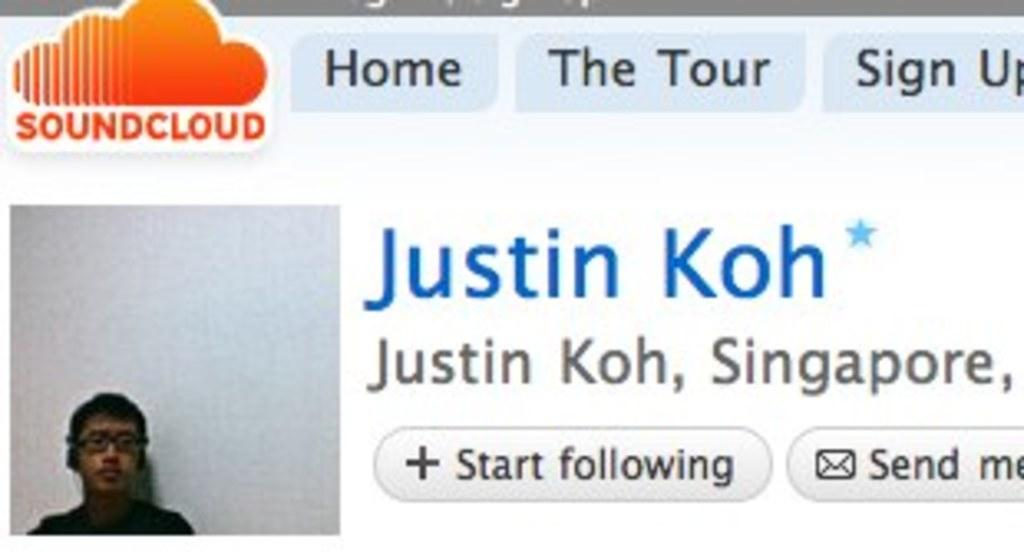Where is the boy located in the image? The boy is in the bottom left hand corner of the image. What can be seen in the top left hand corner of the image? There is a Soundcloud logo in the top left hand corner of the image. What color are the boy's toes in the image? There is no information about the boy's toes in the image, so we cannot determine their color. 